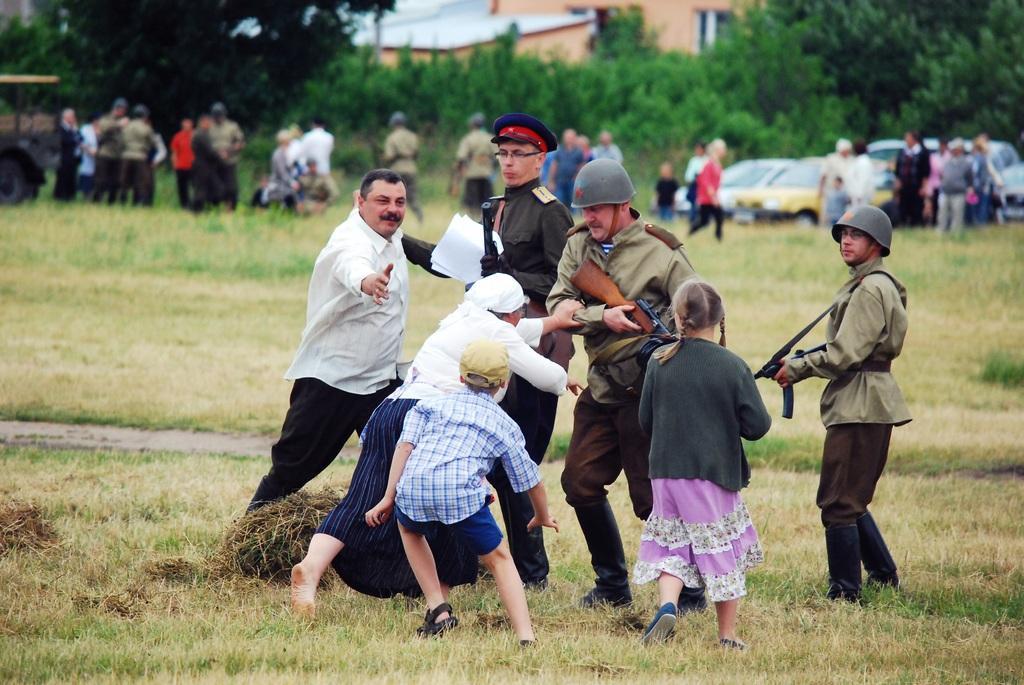Can you describe this image briefly? In this image there are three people holding the guns. In front of them there are people standing. Behind them there are vehicles. There are a few other people. At the bottom of the image there is grass on the surface. In the background of the image there are trees, buildings. 